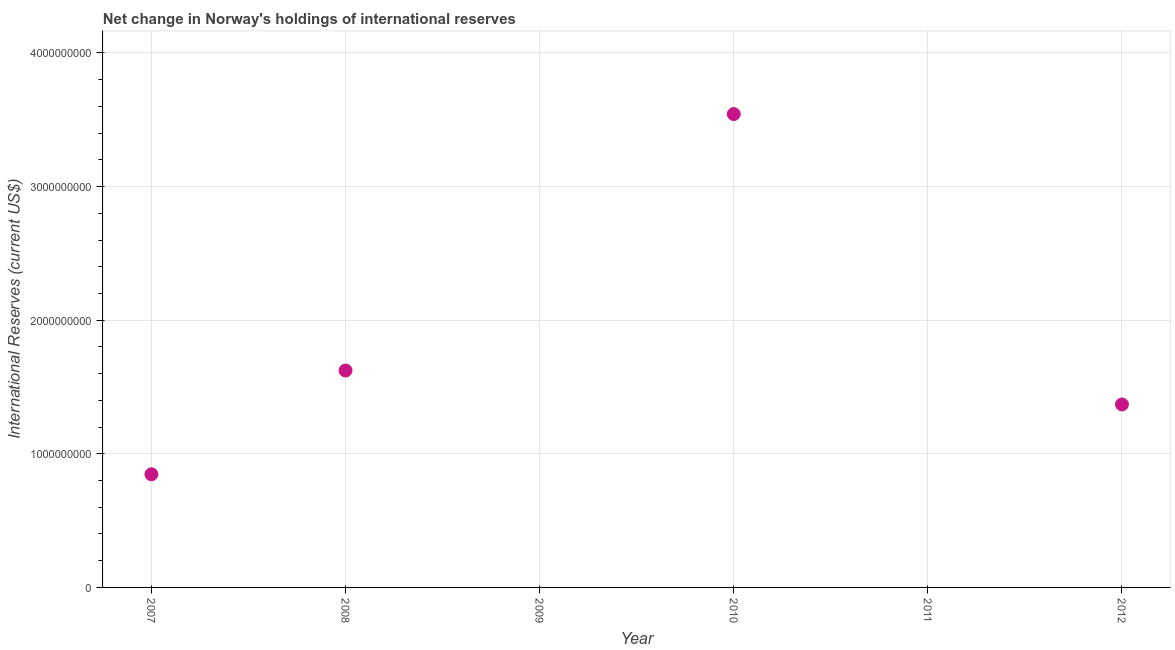What is the reserves and related items in 2011?
Offer a very short reply. 0. Across all years, what is the maximum reserves and related items?
Your answer should be compact. 3.54e+09. Across all years, what is the minimum reserves and related items?
Make the answer very short. 0. What is the sum of the reserves and related items?
Ensure brevity in your answer.  7.38e+09. What is the difference between the reserves and related items in 2008 and 2012?
Give a very brief answer. 2.54e+08. What is the average reserves and related items per year?
Provide a succinct answer. 1.23e+09. What is the median reserves and related items?
Offer a very short reply. 1.11e+09. In how many years, is the reserves and related items greater than 2000000000 US$?
Give a very brief answer. 1. What is the ratio of the reserves and related items in 2008 to that in 2012?
Offer a terse response. 1.19. What is the difference between the highest and the second highest reserves and related items?
Ensure brevity in your answer.  1.92e+09. What is the difference between the highest and the lowest reserves and related items?
Provide a short and direct response. 3.54e+09. Does the reserves and related items monotonically increase over the years?
Offer a terse response. No. How many dotlines are there?
Your answer should be compact. 1. How many years are there in the graph?
Your answer should be compact. 6. What is the difference between two consecutive major ticks on the Y-axis?
Your answer should be compact. 1.00e+09. Are the values on the major ticks of Y-axis written in scientific E-notation?
Offer a terse response. No. Does the graph contain grids?
Ensure brevity in your answer.  Yes. What is the title of the graph?
Give a very brief answer. Net change in Norway's holdings of international reserves. What is the label or title of the X-axis?
Provide a short and direct response. Year. What is the label or title of the Y-axis?
Provide a short and direct response. International Reserves (current US$). What is the International Reserves (current US$) in 2007?
Offer a very short reply. 8.47e+08. What is the International Reserves (current US$) in 2008?
Keep it short and to the point. 1.62e+09. What is the International Reserves (current US$) in 2010?
Provide a succinct answer. 3.54e+09. What is the International Reserves (current US$) in 2012?
Give a very brief answer. 1.37e+09. What is the difference between the International Reserves (current US$) in 2007 and 2008?
Your answer should be compact. -7.76e+08. What is the difference between the International Reserves (current US$) in 2007 and 2010?
Keep it short and to the point. -2.70e+09. What is the difference between the International Reserves (current US$) in 2007 and 2012?
Offer a very short reply. -5.23e+08. What is the difference between the International Reserves (current US$) in 2008 and 2010?
Give a very brief answer. -1.92e+09. What is the difference between the International Reserves (current US$) in 2008 and 2012?
Provide a succinct answer. 2.54e+08. What is the difference between the International Reserves (current US$) in 2010 and 2012?
Provide a short and direct response. 2.17e+09. What is the ratio of the International Reserves (current US$) in 2007 to that in 2008?
Ensure brevity in your answer.  0.52. What is the ratio of the International Reserves (current US$) in 2007 to that in 2010?
Provide a succinct answer. 0.24. What is the ratio of the International Reserves (current US$) in 2007 to that in 2012?
Make the answer very short. 0.62. What is the ratio of the International Reserves (current US$) in 2008 to that in 2010?
Offer a terse response. 0.46. What is the ratio of the International Reserves (current US$) in 2008 to that in 2012?
Offer a very short reply. 1.19. What is the ratio of the International Reserves (current US$) in 2010 to that in 2012?
Offer a terse response. 2.59. 